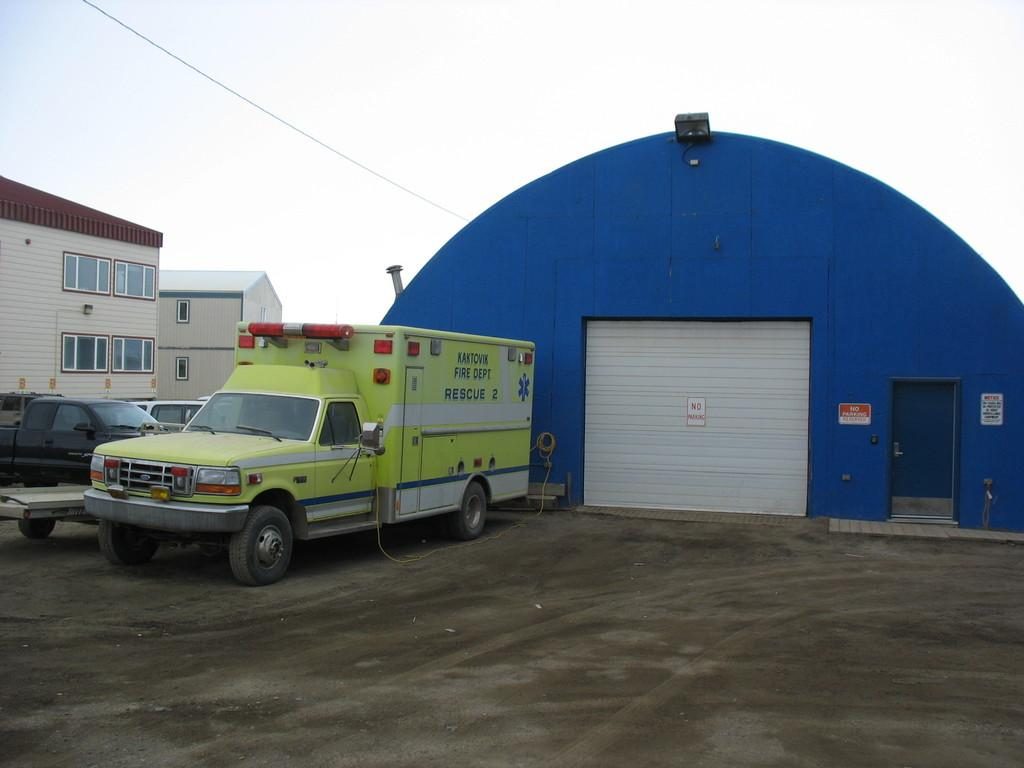What type of vehicles can be seen in the image? There are cars in the image. What type of structures are present in the image? There are homes in the image. What is visible at the top of the image? The sky is visible at the top of the image. What type of income can be seen in the image? There is no reference to income in the image. Can you tell me how many clams are present in the image? There are no clams present in the image. Is there any corn visible in the image? There is no corn present in the image. 